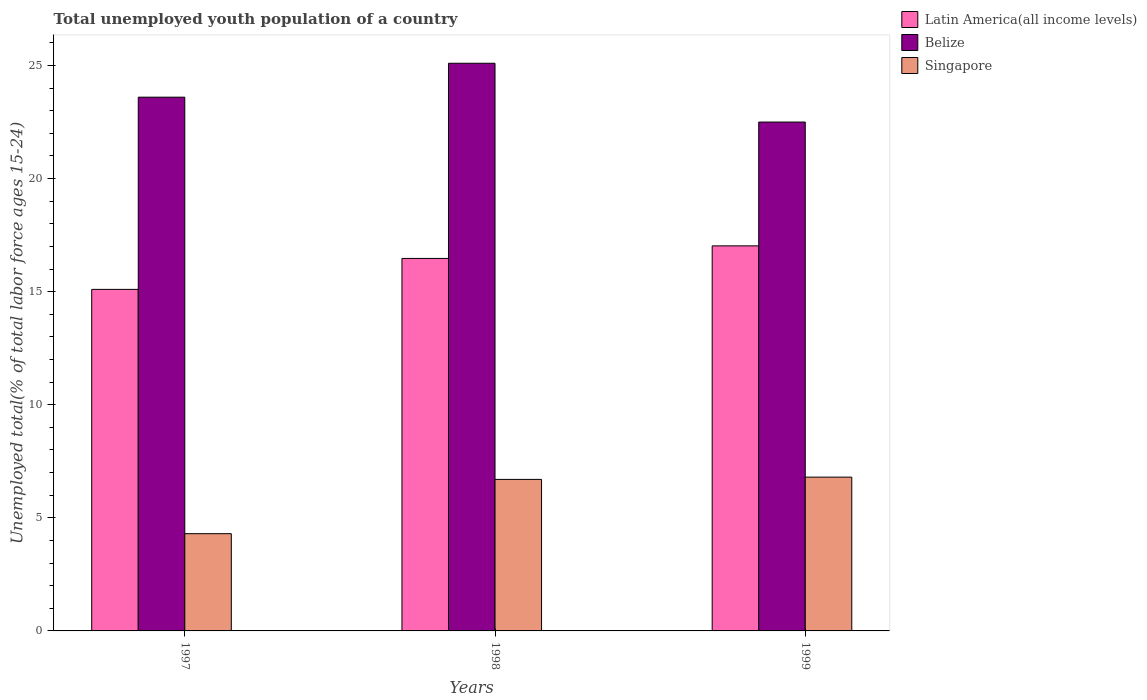Are the number of bars on each tick of the X-axis equal?
Your answer should be very brief. Yes. How many bars are there on the 1st tick from the left?
Provide a succinct answer. 3. What is the label of the 2nd group of bars from the left?
Your answer should be very brief. 1998. What is the percentage of total unemployed youth population of a country in Singapore in 1997?
Ensure brevity in your answer.  4.3. Across all years, what is the maximum percentage of total unemployed youth population of a country in Belize?
Your response must be concise. 25.1. Across all years, what is the minimum percentage of total unemployed youth population of a country in Singapore?
Offer a terse response. 4.3. In which year was the percentage of total unemployed youth population of a country in Singapore maximum?
Offer a terse response. 1999. What is the total percentage of total unemployed youth population of a country in Singapore in the graph?
Give a very brief answer. 17.8. What is the difference between the percentage of total unemployed youth population of a country in Belize in 1997 and that in 1998?
Provide a succinct answer. -1.5. What is the difference between the percentage of total unemployed youth population of a country in Belize in 1997 and the percentage of total unemployed youth population of a country in Latin America(all income levels) in 1998?
Your response must be concise. 7.13. What is the average percentage of total unemployed youth population of a country in Latin America(all income levels) per year?
Offer a terse response. 16.2. In the year 1998, what is the difference between the percentage of total unemployed youth population of a country in Singapore and percentage of total unemployed youth population of a country in Latin America(all income levels)?
Your response must be concise. -9.77. What is the ratio of the percentage of total unemployed youth population of a country in Singapore in 1997 to that in 1998?
Keep it short and to the point. 0.64. Is the percentage of total unemployed youth population of a country in Singapore in 1997 less than that in 1999?
Your response must be concise. Yes. Is the difference between the percentage of total unemployed youth population of a country in Singapore in 1997 and 1998 greater than the difference between the percentage of total unemployed youth population of a country in Latin America(all income levels) in 1997 and 1998?
Give a very brief answer. No. What is the difference between the highest and the second highest percentage of total unemployed youth population of a country in Latin America(all income levels)?
Your response must be concise. 0.56. What is the difference between the highest and the lowest percentage of total unemployed youth population of a country in Belize?
Your answer should be very brief. 2.6. Is the sum of the percentage of total unemployed youth population of a country in Latin America(all income levels) in 1997 and 1998 greater than the maximum percentage of total unemployed youth population of a country in Singapore across all years?
Provide a short and direct response. Yes. What does the 2nd bar from the left in 1998 represents?
Provide a succinct answer. Belize. What does the 3rd bar from the right in 1998 represents?
Offer a terse response. Latin America(all income levels). Are all the bars in the graph horizontal?
Your response must be concise. No. What is the difference between two consecutive major ticks on the Y-axis?
Keep it short and to the point. 5. Are the values on the major ticks of Y-axis written in scientific E-notation?
Make the answer very short. No. Does the graph contain grids?
Ensure brevity in your answer.  No. How many legend labels are there?
Offer a terse response. 3. What is the title of the graph?
Your response must be concise. Total unemployed youth population of a country. What is the label or title of the X-axis?
Your answer should be compact. Years. What is the label or title of the Y-axis?
Your answer should be very brief. Unemployed total(% of total labor force ages 15-24). What is the Unemployed total(% of total labor force ages 15-24) of Latin America(all income levels) in 1997?
Your response must be concise. 15.1. What is the Unemployed total(% of total labor force ages 15-24) in Belize in 1997?
Provide a short and direct response. 23.6. What is the Unemployed total(% of total labor force ages 15-24) of Singapore in 1997?
Provide a succinct answer. 4.3. What is the Unemployed total(% of total labor force ages 15-24) in Latin America(all income levels) in 1998?
Give a very brief answer. 16.47. What is the Unemployed total(% of total labor force ages 15-24) in Belize in 1998?
Provide a short and direct response. 25.1. What is the Unemployed total(% of total labor force ages 15-24) in Singapore in 1998?
Provide a succinct answer. 6.7. What is the Unemployed total(% of total labor force ages 15-24) in Latin America(all income levels) in 1999?
Provide a succinct answer. 17.03. What is the Unemployed total(% of total labor force ages 15-24) in Belize in 1999?
Provide a short and direct response. 22.5. What is the Unemployed total(% of total labor force ages 15-24) of Singapore in 1999?
Keep it short and to the point. 6.8. Across all years, what is the maximum Unemployed total(% of total labor force ages 15-24) in Latin America(all income levels)?
Give a very brief answer. 17.03. Across all years, what is the maximum Unemployed total(% of total labor force ages 15-24) in Belize?
Give a very brief answer. 25.1. Across all years, what is the maximum Unemployed total(% of total labor force ages 15-24) in Singapore?
Make the answer very short. 6.8. Across all years, what is the minimum Unemployed total(% of total labor force ages 15-24) in Latin America(all income levels)?
Provide a short and direct response. 15.1. Across all years, what is the minimum Unemployed total(% of total labor force ages 15-24) in Belize?
Your answer should be very brief. 22.5. Across all years, what is the minimum Unemployed total(% of total labor force ages 15-24) in Singapore?
Provide a succinct answer. 4.3. What is the total Unemployed total(% of total labor force ages 15-24) of Latin America(all income levels) in the graph?
Your response must be concise. 48.6. What is the total Unemployed total(% of total labor force ages 15-24) in Belize in the graph?
Provide a short and direct response. 71.2. What is the total Unemployed total(% of total labor force ages 15-24) in Singapore in the graph?
Offer a terse response. 17.8. What is the difference between the Unemployed total(% of total labor force ages 15-24) of Latin America(all income levels) in 1997 and that in 1998?
Provide a succinct answer. -1.37. What is the difference between the Unemployed total(% of total labor force ages 15-24) in Belize in 1997 and that in 1998?
Keep it short and to the point. -1.5. What is the difference between the Unemployed total(% of total labor force ages 15-24) of Singapore in 1997 and that in 1998?
Your response must be concise. -2.4. What is the difference between the Unemployed total(% of total labor force ages 15-24) in Latin America(all income levels) in 1997 and that in 1999?
Give a very brief answer. -1.92. What is the difference between the Unemployed total(% of total labor force ages 15-24) of Belize in 1997 and that in 1999?
Provide a succinct answer. 1.1. What is the difference between the Unemployed total(% of total labor force ages 15-24) in Singapore in 1997 and that in 1999?
Ensure brevity in your answer.  -2.5. What is the difference between the Unemployed total(% of total labor force ages 15-24) of Latin America(all income levels) in 1998 and that in 1999?
Your answer should be very brief. -0.56. What is the difference between the Unemployed total(% of total labor force ages 15-24) of Belize in 1998 and that in 1999?
Make the answer very short. 2.6. What is the difference between the Unemployed total(% of total labor force ages 15-24) of Singapore in 1998 and that in 1999?
Offer a very short reply. -0.1. What is the difference between the Unemployed total(% of total labor force ages 15-24) of Latin America(all income levels) in 1997 and the Unemployed total(% of total labor force ages 15-24) of Belize in 1998?
Give a very brief answer. -10. What is the difference between the Unemployed total(% of total labor force ages 15-24) of Latin America(all income levels) in 1997 and the Unemployed total(% of total labor force ages 15-24) of Singapore in 1998?
Your answer should be compact. 8.4. What is the difference between the Unemployed total(% of total labor force ages 15-24) of Belize in 1997 and the Unemployed total(% of total labor force ages 15-24) of Singapore in 1998?
Give a very brief answer. 16.9. What is the difference between the Unemployed total(% of total labor force ages 15-24) of Latin America(all income levels) in 1997 and the Unemployed total(% of total labor force ages 15-24) of Belize in 1999?
Offer a terse response. -7.4. What is the difference between the Unemployed total(% of total labor force ages 15-24) of Latin America(all income levels) in 1997 and the Unemployed total(% of total labor force ages 15-24) of Singapore in 1999?
Offer a terse response. 8.3. What is the difference between the Unemployed total(% of total labor force ages 15-24) in Belize in 1997 and the Unemployed total(% of total labor force ages 15-24) in Singapore in 1999?
Your answer should be compact. 16.8. What is the difference between the Unemployed total(% of total labor force ages 15-24) of Latin America(all income levels) in 1998 and the Unemployed total(% of total labor force ages 15-24) of Belize in 1999?
Keep it short and to the point. -6.03. What is the difference between the Unemployed total(% of total labor force ages 15-24) of Latin America(all income levels) in 1998 and the Unemployed total(% of total labor force ages 15-24) of Singapore in 1999?
Your response must be concise. 9.67. What is the difference between the Unemployed total(% of total labor force ages 15-24) of Belize in 1998 and the Unemployed total(% of total labor force ages 15-24) of Singapore in 1999?
Make the answer very short. 18.3. What is the average Unemployed total(% of total labor force ages 15-24) of Latin America(all income levels) per year?
Offer a very short reply. 16.2. What is the average Unemployed total(% of total labor force ages 15-24) of Belize per year?
Provide a short and direct response. 23.73. What is the average Unemployed total(% of total labor force ages 15-24) of Singapore per year?
Offer a very short reply. 5.93. In the year 1997, what is the difference between the Unemployed total(% of total labor force ages 15-24) of Latin America(all income levels) and Unemployed total(% of total labor force ages 15-24) of Belize?
Offer a very short reply. -8.5. In the year 1997, what is the difference between the Unemployed total(% of total labor force ages 15-24) of Latin America(all income levels) and Unemployed total(% of total labor force ages 15-24) of Singapore?
Provide a succinct answer. 10.8. In the year 1997, what is the difference between the Unemployed total(% of total labor force ages 15-24) in Belize and Unemployed total(% of total labor force ages 15-24) in Singapore?
Your answer should be very brief. 19.3. In the year 1998, what is the difference between the Unemployed total(% of total labor force ages 15-24) of Latin America(all income levels) and Unemployed total(% of total labor force ages 15-24) of Belize?
Offer a very short reply. -8.63. In the year 1998, what is the difference between the Unemployed total(% of total labor force ages 15-24) of Latin America(all income levels) and Unemployed total(% of total labor force ages 15-24) of Singapore?
Offer a terse response. 9.77. In the year 1998, what is the difference between the Unemployed total(% of total labor force ages 15-24) of Belize and Unemployed total(% of total labor force ages 15-24) of Singapore?
Offer a terse response. 18.4. In the year 1999, what is the difference between the Unemployed total(% of total labor force ages 15-24) in Latin America(all income levels) and Unemployed total(% of total labor force ages 15-24) in Belize?
Offer a terse response. -5.47. In the year 1999, what is the difference between the Unemployed total(% of total labor force ages 15-24) in Latin America(all income levels) and Unemployed total(% of total labor force ages 15-24) in Singapore?
Your answer should be compact. 10.23. In the year 1999, what is the difference between the Unemployed total(% of total labor force ages 15-24) of Belize and Unemployed total(% of total labor force ages 15-24) of Singapore?
Your answer should be compact. 15.7. What is the ratio of the Unemployed total(% of total labor force ages 15-24) in Latin America(all income levels) in 1997 to that in 1998?
Keep it short and to the point. 0.92. What is the ratio of the Unemployed total(% of total labor force ages 15-24) of Belize in 1997 to that in 1998?
Your response must be concise. 0.94. What is the ratio of the Unemployed total(% of total labor force ages 15-24) of Singapore in 1997 to that in 1998?
Your response must be concise. 0.64. What is the ratio of the Unemployed total(% of total labor force ages 15-24) in Latin America(all income levels) in 1997 to that in 1999?
Offer a terse response. 0.89. What is the ratio of the Unemployed total(% of total labor force ages 15-24) in Belize in 1997 to that in 1999?
Provide a short and direct response. 1.05. What is the ratio of the Unemployed total(% of total labor force ages 15-24) of Singapore in 1997 to that in 1999?
Make the answer very short. 0.63. What is the ratio of the Unemployed total(% of total labor force ages 15-24) in Latin America(all income levels) in 1998 to that in 1999?
Offer a terse response. 0.97. What is the ratio of the Unemployed total(% of total labor force ages 15-24) in Belize in 1998 to that in 1999?
Offer a very short reply. 1.12. What is the ratio of the Unemployed total(% of total labor force ages 15-24) in Singapore in 1998 to that in 1999?
Your answer should be very brief. 0.99. What is the difference between the highest and the second highest Unemployed total(% of total labor force ages 15-24) of Latin America(all income levels)?
Your response must be concise. 0.56. What is the difference between the highest and the second highest Unemployed total(% of total labor force ages 15-24) in Belize?
Your answer should be compact. 1.5. What is the difference between the highest and the second highest Unemployed total(% of total labor force ages 15-24) of Singapore?
Offer a terse response. 0.1. What is the difference between the highest and the lowest Unemployed total(% of total labor force ages 15-24) of Latin America(all income levels)?
Make the answer very short. 1.92. What is the difference between the highest and the lowest Unemployed total(% of total labor force ages 15-24) in Belize?
Ensure brevity in your answer.  2.6. 